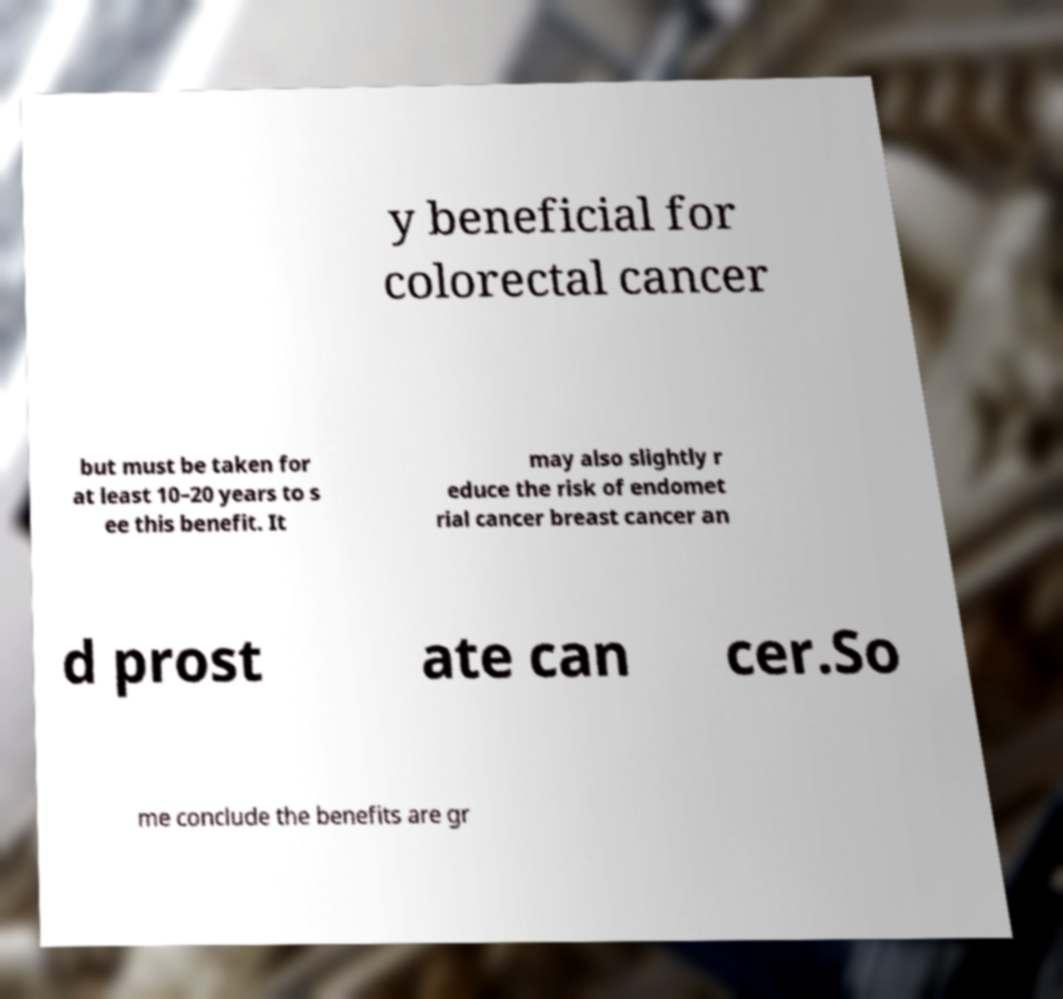For documentation purposes, I need the text within this image transcribed. Could you provide that? y beneficial for colorectal cancer but must be taken for at least 10–20 years to s ee this benefit. It may also slightly r educe the risk of endomet rial cancer breast cancer an d prost ate can cer.So me conclude the benefits are gr 